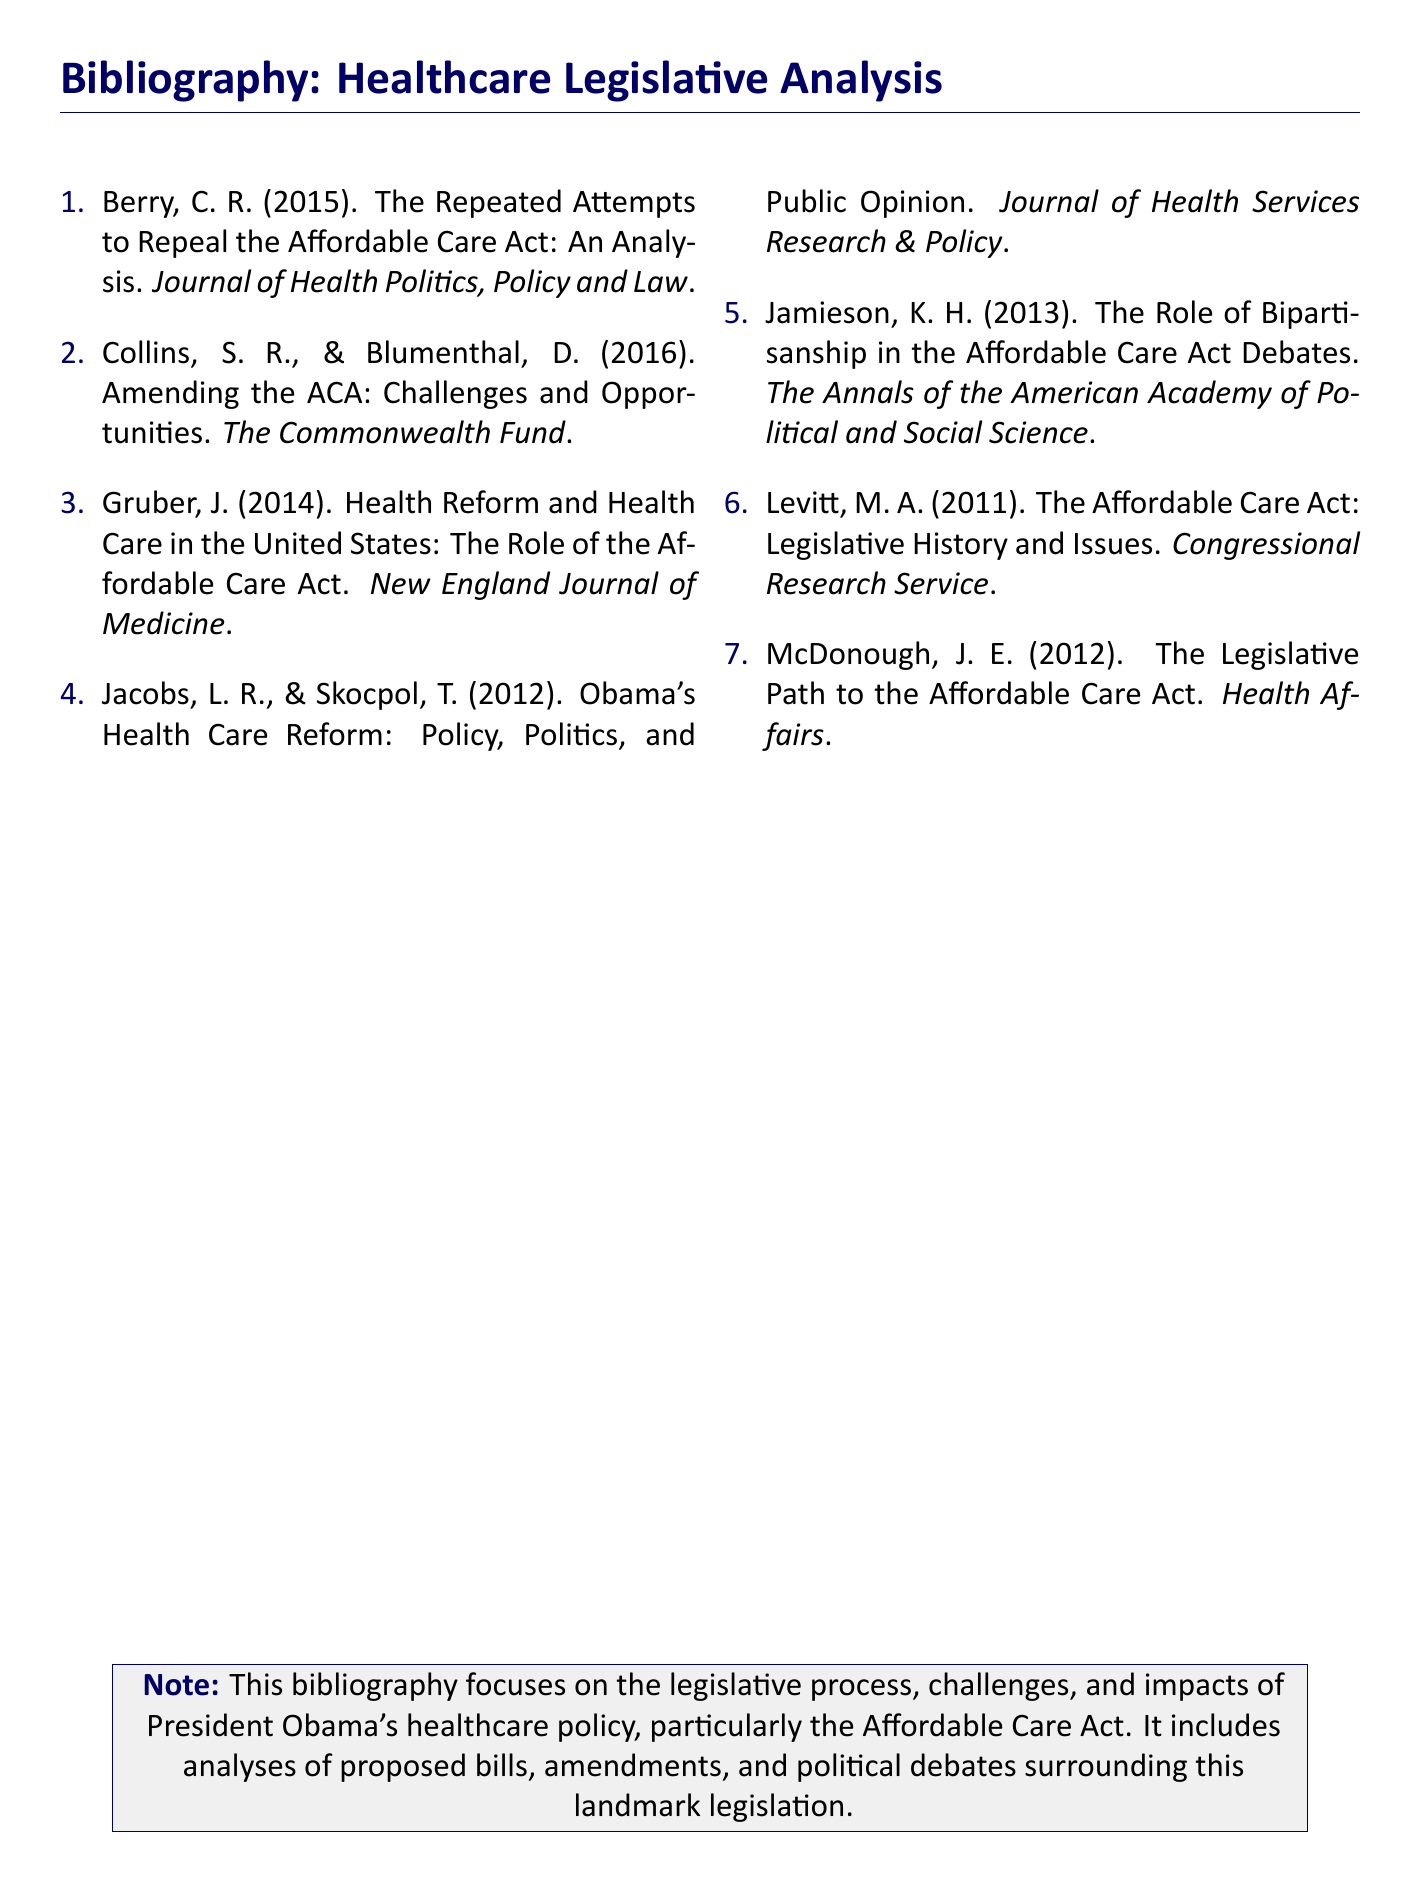What is the title of the first entry in the bibliography? The title of the first entry is "The Repeated Attempts to Repeal the Affordable Care Act: An Analysis."
Answer: The Repeated Attempts to Repeal the Affordable Care Act: An Analysis Who are the authors of the second entry? The authors of the second entry are Collins and Blumenthal.
Answer: Collins, S. R., & Blumenthal, D What year was the legislative history of the Affordable Care Act published? The legislative history was published in 2011.
Answer: 2011 Which journal published the article by Gruber? The article by Gruber was published in the New England Journal of Medicine.
Answer: New England Journal of Medicine How many entries are included in the bibliography? The bibliography includes a total of seven entries.
Answer: Seven What is the focus of the bibliography? The focus of the bibliography is on the legislative process, challenges, and impacts of President Obama's healthcare policy.
Answer: Legislative process, challenges, and impacts of President Obama's healthcare policy Which entry discusses the role of bipartisanship in the ACA debates? The entry that discusses this is by Jamieson.
Answer: Jamieson In what document format is this bibliography presented? The document format of this bibliography is an article.
Answer: Article 